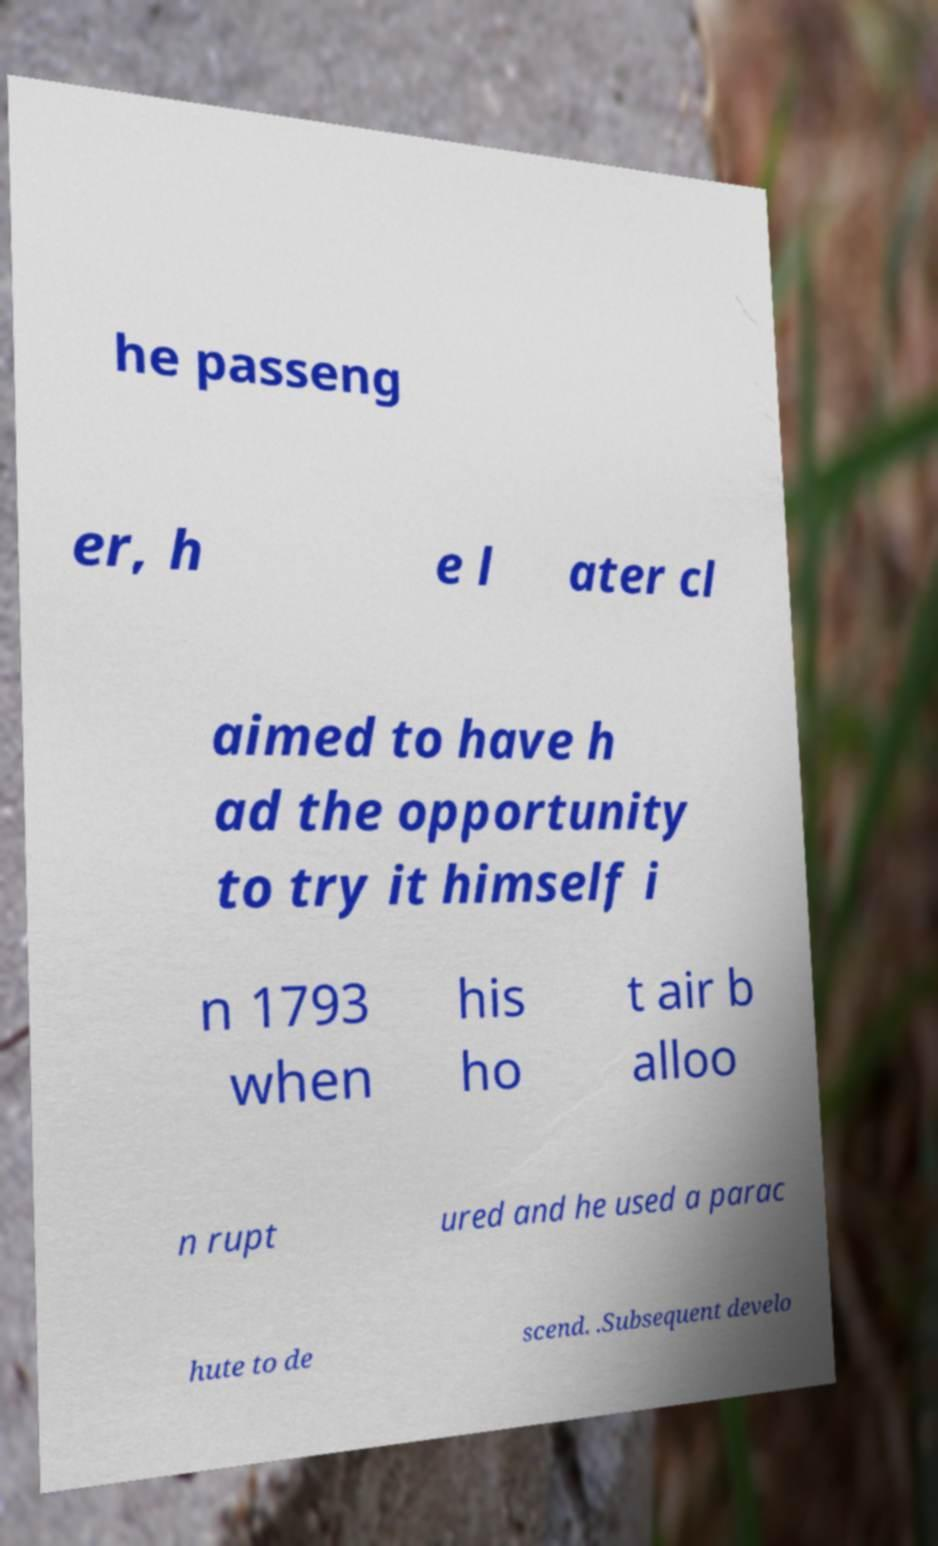What messages or text are displayed in this image? I need them in a readable, typed format. he passeng er, h e l ater cl aimed to have h ad the opportunity to try it himself i n 1793 when his ho t air b alloo n rupt ured and he used a parac hute to de scend. .Subsequent develo 